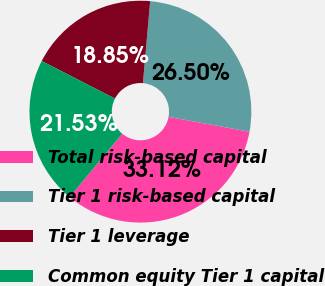Convert chart. <chart><loc_0><loc_0><loc_500><loc_500><pie_chart><fcel>Total risk-based capital<fcel>Tier 1 risk-based capital<fcel>Tier 1 leverage<fcel>Common equity Tier 1 capital<nl><fcel>33.12%<fcel>26.5%<fcel>18.85%<fcel>21.53%<nl></chart> 